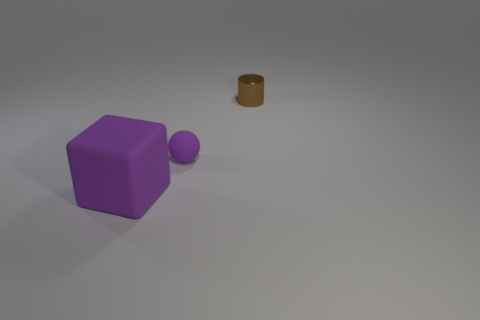What is the shape of the brown shiny thing?
Your answer should be very brief. Cylinder. Is the material of the block the same as the tiny thing that is to the left of the small brown cylinder?
Your response must be concise. Yes. What number of metal things are either large spheres or cylinders?
Make the answer very short. 1. What size is the purple rubber thing that is in front of the tiny matte sphere?
Give a very brief answer. Large. What size is the purple cube that is made of the same material as the tiny purple ball?
Your response must be concise. Large. How many blocks have the same color as the large thing?
Give a very brief answer. 0. Is there a large red rubber cylinder?
Provide a short and direct response. No. Do the small purple matte thing and the small brown object right of the purple matte block have the same shape?
Give a very brief answer. No. There is a small metal object that is behind the object that is to the left of the rubber object that is on the right side of the rubber cube; what color is it?
Offer a very short reply. Brown. Are there any small brown cylinders in front of the purple matte cube?
Your answer should be compact. No. 